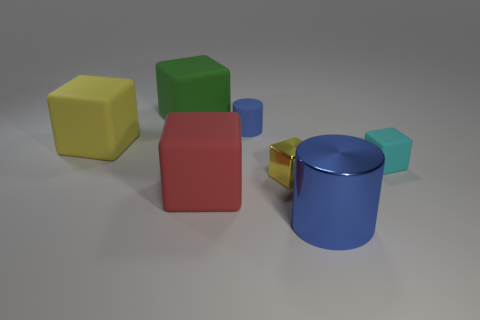Subtract all green cubes. How many cubes are left? 4 Subtract all cyan rubber blocks. How many blocks are left? 4 Subtract all blue blocks. Subtract all brown balls. How many blocks are left? 5 Add 1 big purple matte things. How many objects exist? 8 Subtract all blocks. How many objects are left? 2 Add 1 yellow shiny things. How many yellow shiny things are left? 2 Add 7 large matte objects. How many large matte objects exist? 10 Subtract 2 blue cylinders. How many objects are left? 5 Subtract all purple rubber objects. Subtract all cubes. How many objects are left? 2 